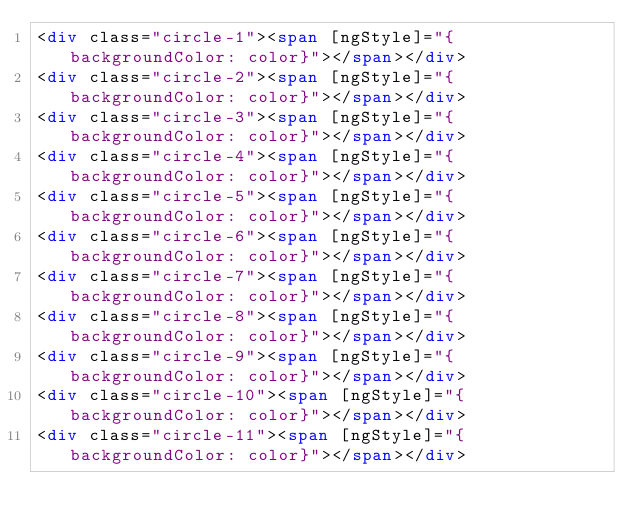<code> <loc_0><loc_0><loc_500><loc_500><_HTML_><div class="circle-1"><span [ngStyle]="{backgroundColor: color}"></span></div>
<div class="circle-2"><span [ngStyle]="{backgroundColor: color}"></span></div>
<div class="circle-3"><span [ngStyle]="{backgroundColor: color}"></span></div>
<div class="circle-4"><span [ngStyle]="{backgroundColor: color}"></span></div>
<div class="circle-5"><span [ngStyle]="{backgroundColor: color}"></span></div>
<div class="circle-6"><span [ngStyle]="{backgroundColor: color}"></span></div>
<div class="circle-7"><span [ngStyle]="{backgroundColor: color}"></span></div>
<div class="circle-8"><span [ngStyle]="{backgroundColor: color}"></span></div>
<div class="circle-9"><span [ngStyle]="{backgroundColor: color}"></span></div>
<div class="circle-10"><span [ngStyle]="{backgroundColor: color}"></span></div>
<div class="circle-11"><span [ngStyle]="{backgroundColor: color}"></span></div></code> 